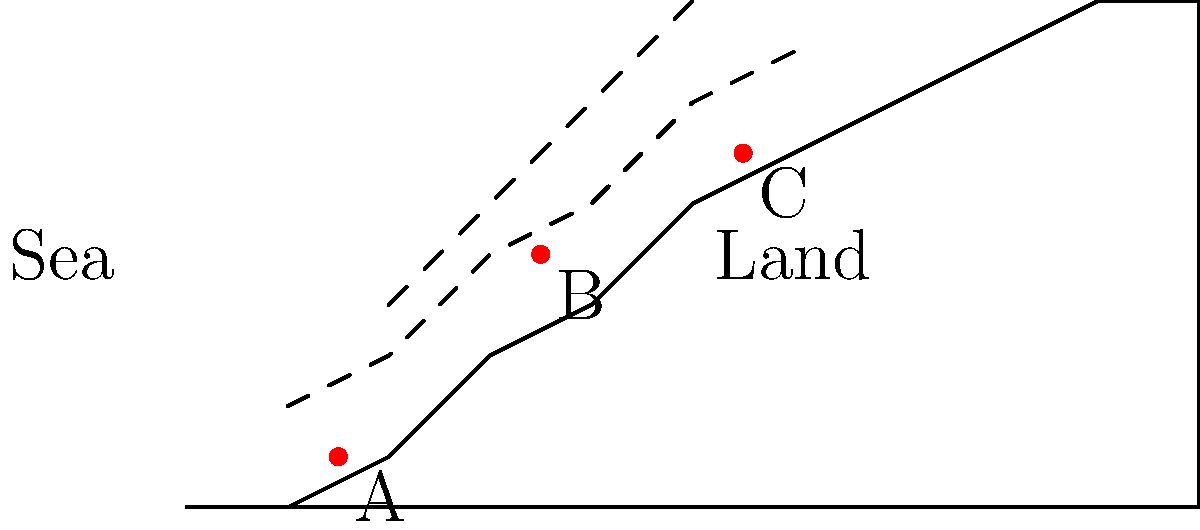Based on the topographical map of a section of the Falkland Islands, which of the three marked positions (A, B, or C) would provide the best defensive advantage for Argentine forces against a potential British amphibious assault? To determine the best defensive position, we need to consider several factors:

1. Elevation: Higher ground provides better visibility and defensive advantage.
2. Distance from the coast: Positions further inland are harder to reach for amphibious forces.
3. Terrain features: Natural barriers can enhance defensive capabilities.

Analyzing each position:

A. Low elevation, close to the coast. Vulnerable to direct assault and offers limited visibility.

B. Mid-elevation, moderate distance from the coast. Provides better visibility and more time to respond to incoming threats.

C. Highest elevation, furthest from the coast. Offers the best visibility, longest response time, and natural high ground advantage.

Position C provides the following advantages:
1. Highest elevation, allowing for the best observation of enemy movements.
2. Greatest distance from the coast, giving more time to prepare for and respond to an assault.
3. Natural high ground, providing a tactical advantage in combat situations.
4. Potential for creating strong fortifications due to the terrain.

Therefore, Position C would provide the best defensive advantage for Argentine forces against a potential British amphibious assault.
Answer: Position C 